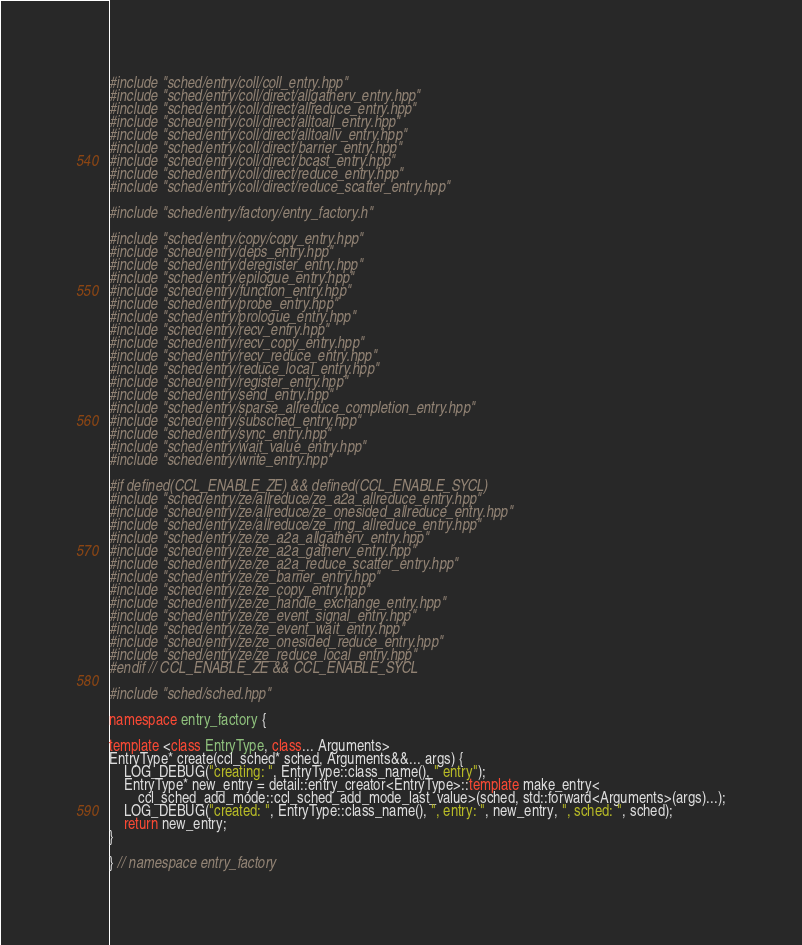Convert code to text. <code><loc_0><loc_0><loc_500><loc_500><_C++_>#include "sched/entry/coll/coll_entry.hpp"
#include "sched/entry/coll/direct/allgatherv_entry.hpp"
#include "sched/entry/coll/direct/allreduce_entry.hpp"
#include "sched/entry/coll/direct/alltoall_entry.hpp"
#include "sched/entry/coll/direct/alltoallv_entry.hpp"
#include "sched/entry/coll/direct/barrier_entry.hpp"
#include "sched/entry/coll/direct/bcast_entry.hpp"
#include "sched/entry/coll/direct/reduce_entry.hpp"
#include "sched/entry/coll/direct/reduce_scatter_entry.hpp"

#include "sched/entry/factory/entry_factory.h"

#include "sched/entry/copy/copy_entry.hpp"
#include "sched/entry/deps_entry.hpp"
#include "sched/entry/deregister_entry.hpp"
#include "sched/entry/epilogue_entry.hpp"
#include "sched/entry/function_entry.hpp"
#include "sched/entry/probe_entry.hpp"
#include "sched/entry/prologue_entry.hpp"
#include "sched/entry/recv_entry.hpp"
#include "sched/entry/recv_copy_entry.hpp"
#include "sched/entry/recv_reduce_entry.hpp"
#include "sched/entry/reduce_local_entry.hpp"
#include "sched/entry/register_entry.hpp"
#include "sched/entry/send_entry.hpp"
#include "sched/entry/sparse_allreduce_completion_entry.hpp"
#include "sched/entry/subsched_entry.hpp"
#include "sched/entry/sync_entry.hpp"
#include "sched/entry/wait_value_entry.hpp"
#include "sched/entry/write_entry.hpp"

#if defined(CCL_ENABLE_ZE) && defined(CCL_ENABLE_SYCL)
#include "sched/entry/ze/allreduce/ze_a2a_allreduce_entry.hpp"
#include "sched/entry/ze/allreduce/ze_onesided_allreduce_entry.hpp"
#include "sched/entry/ze/allreduce/ze_ring_allreduce_entry.hpp"
#include "sched/entry/ze/ze_a2a_allgatherv_entry.hpp"
#include "sched/entry/ze/ze_a2a_gatherv_entry.hpp"
#include "sched/entry/ze/ze_a2a_reduce_scatter_entry.hpp"
#include "sched/entry/ze/ze_barrier_entry.hpp"
#include "sched/entry/ze/ze_copy_entry.hpp"
#include "sched/entry/ze/ze_handle_exchange_entry.hpp"
#include "sched/entry/ze/ze_event_signal_entry.hpp"
#include "sched/entry/ze/ze_event_wait_entry.hpp"
#include "sched/entry/ze/ze_onesided_reduce_entry.hpp"
#include "sched/entry/ze/ze_reduce_local_entry.hpp"
#endif // CCL_ENABLE_ZE && CCL_ENABLE_SYCL

#include "sched/sched.hpp"

namespace entry_factory {

template <class EntryType, class... Arguments>
EntryType* create(ccl_sched* sched, Arguments&&... args) {
    LOG_DEBUG("creating: ", EntryType::class_name(), " entry");
    EntryType* new_entry = detail::entry_creator<EntryType>::template make_entry<
        ccl_sched_add_mode::ccl_sched_add_mode_last_value>(sched, std::forward<Arguments>(args)...);
    LOG_DEBUG("created: ", EntryType::class_name(), ", entry: ", new_entry, ", sched: ", sched);
    return new_entry;
}

} // namespace entry_factory
</code> 